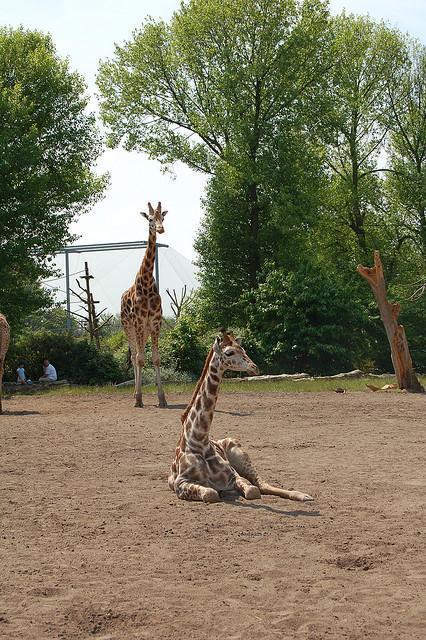How many giraffes are laying down?
Give a very brief answer. 1. How many giraffes are there?
Give a very brief answer. 2. 